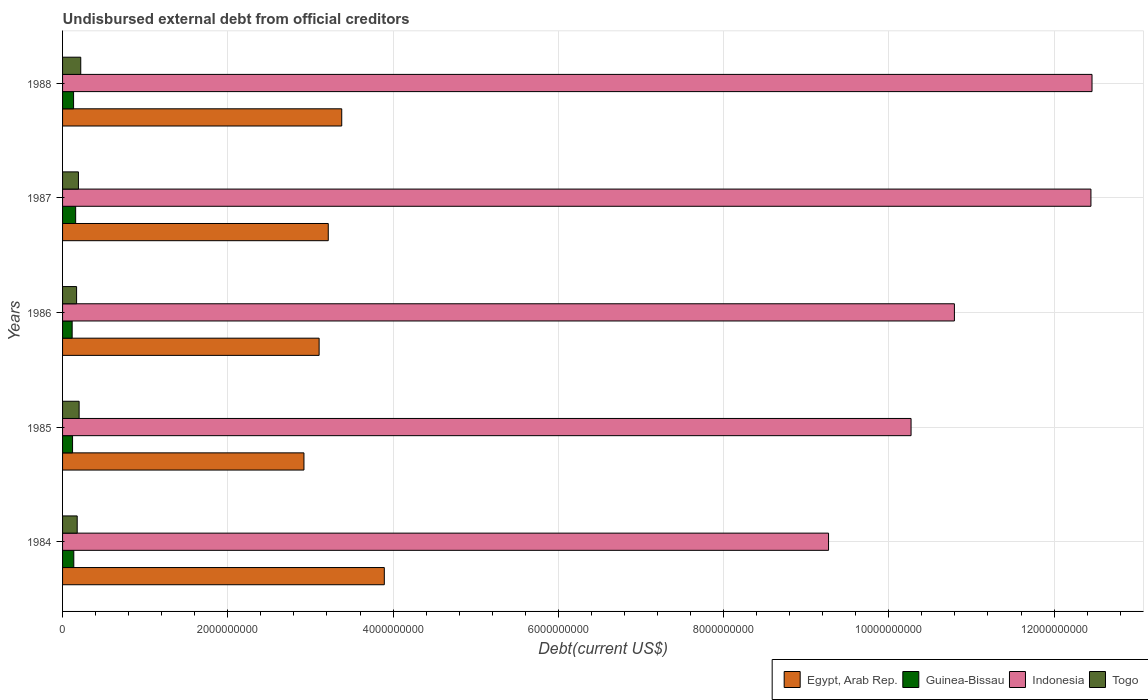How many different coloured bars are there?
Your answer should be very brief. 4. Are the number of bars per tick equal to the number of legend labels?
Your answer should be compact. Yes. Are the number of bars on each tick of the Y-axis equal?
Your answer should be compact. Yes. How many bars are there on the 2nd tick from the top?
Provide a succinct answer. 4. What is the label of the 4th group of bars from the top?
Ensure brevity in your answer.  1985. In how many cases, is the number of bars for a given year not equal to the number of legend labels?
Your response must be concise. 0. What is the total debt in Indonesia in 1985?
Give a very brief answer. 1.03e+1. Across all years, what is the maximum total debt in Togo?
Your response must be concise. 2.20e+08. Across all years, what is the minimum total debt in Egypt, Arab Rep.?
Your answer should be very brief. 2.92e+09. What is the total total debt in Guinea-Bissau in the graph?
Keep it short and to the point. 6.65e+08. What is the difference between the total debt in Guinea-Bissau in 1984 and that in 1985?
Provide a short and direct response. 1.49e+07. What is the difference between the total debt in Egypt, Arab Rep. in 1987 and the total debt in Guinea-Bissau in 1986?
Ensure brevity in your answer.  3.10e+09. What is the average total debt in Guinea-Bissau per year?
Your response must be concise. 1.33e+08. In the year 1988, what is the difference between the total debt in Indonesia and total debt in Togo?
Your answer should be compact. 1.22e+1. In how many years, is the total debt in Egypt, Arab Rep. greater than 7600000000 US$?
Provide a short and direct response. 0. What is the ratio of the total debt in Indonesia in 1984 to that in 1985?
Provide a succinct answer. 0.9. Is the total debt in Togo in 1984 less than that in 1988?
Provide a succinct answer. Yes. Is the difference between the total debt in Indonesia in 1985 and 1988 greater than the difference between the total debt in Togo in 1985 and 1988?
Your answer should be very brief. No. What is the difference between the highest and the second highest total debt in Egypt, Arab Rep.?
Offer a very short reply. 5.15e+08. What is the difference between the highest and the lowest total debt in Guinea-Bissau?
Ensure brevity in your answer.  4.24e+07. In how many years, is the total debt in Indonesia greater than the average total debt in Indonesia taken over all years?
Offer a very short reply. 2. What does the 3rd bar from the top in 1988 represents?
Offer a very short reply. Guinea-Bissau. What does the 4th bar from the bottom in 1988 represents?
Offer a very short reply. Togo. How many bars are there?
Offer a terse response. 20. Are all the bars in the graph horizontal?
Offer a very short reply. Yes. How many years are there in the graph?
Your response must be concise. 5. Does the graph contain any zero values?
Offer a very short reply. No. How are the legend labels stacked?
Your response must be concise. Horizontal. What is the title of the graph?
Your answer should be compact. Undisbursed external debt from official creditors. Does "Marshall Islands" appear as one of the legend labels in the graph?
Your answer should be compact. No. What is the label or title of the X-axis?
Ensure brevity in your answer.  Debt(current US$). What is the Debt(current US$) in Egypt, Arab Rep. in 1984?
Your response must be concise. 3.89e+09. What is the Debt(current US$) of Guinea-Bissau in 1984?
Your answer should be compact. 1.36e+08. What is the Debt(current US$) of Indonesia in 1984?
Keep it short and to the point. 9.27e+09. What is the Debt(current US$) of Togo in 1984?
Keep it short and to the point. 1.77e+08. What is the Debt(current US$) of Egypt, Arab Rep. in 1985?
Your response must be concise. 2.92e+09. What is the Debt(current US$) in Guinea-Bissau in 1985?
Your response must be concise. 1.21e+08. What is the Debt(current US$) in Indonesia in 1985?
Your response must be concise. 1.03e+1. What is the Debt(current US$) in Togo in 1985?
Your answer should be very brief. 2.00e+08. What is the Debt(current US$) of Egypt, Arab Rep. in 1986?
Keep it short and to the point. 3.11e+09. What is the Debt(current US$) in Guinea-Bissau in 1986?
Give a very brief answer. 1.16e+08. What is the Debt(current US$) of Indonesia in 1986?
Provide a short and direct response. 1.08e+1. What is the Debt(current US$) in Togo in 1986?
Your answer should be very brief. 1.70e+08. What is the Debt(current US$) of Egypt, Arab Rep. in 1987?
Provide a short and direct response. 3.22e+09. What is the Debt(current US$) of Guinea-Bissau in 1987?
Your answer should be compact. 1.59e+08. What is the Debt(current US$) in Indonesia in 1987?
Your answer should be very brief. 1.24e+1. What is the Debt(current US$) of Togo in 1987?
Your answer should be very brief. 1.92e+08. What is the Debt(current US$) of Egypt, Arab Rep. in 1988?
Provide a succinct answer. 3.38e+09. What is the Debt(current US$) of Guinea-Bissau in 1988?
Give a very brief answer. 1.33e+08. What is the Debt(current US$) in Indonesia in 1988?
Ensure brevity in your answer.  1.25e+1. What is the Debt(current US$) in Togo in 1988?
Make the answer very short. 2.20e+08. Across all years, what is the maximum Debt(current US$) in Egypt, Arab Rep.?
Make the answer very short. 3.89e+09. Across all years, what is the maximum Debt(current US$) in Guinea-Bissau?
Ensure brevity in your answer.  1.59e+08. Across all years, what is the maximum Debt(current US$) of Indonesia?
Give a very brief answer. 1.25e+1. Across all years, what is the maximum Debt(current US$) in Togo?
Offer a very short reply. 2.20e+08. Across all years, what is the minimum Debt(current US$) in Egypt, Arab Rep.?
Offer a terse response. 2.92e+09. Across all years, what is the minimum Debt(current US$) in Guinea-Bissau?
Give a very brief answer. 1.16e+08. Across all years, what is the minimum Debt(current US$) of Indonesia?
Your answer should be very brief. 9.27e+09. Across all years, what is the minimum Debt(current US$) of Togo?
Offer a very short reply. 1.70e+08. What is the total Debt(current US$) of Egypt, Arab Rep. in the graph?
Keep it short and to the point. 1.65e+1. What is the total Debt(current US$) in Guinea-Bissau in the graph?
Provide a short and direct response. 6.65e+08. What is the total Debt(current US$) of Indonesia in the graph?
Your answer should be very brief. 5.52e+1. What is the total Debt(current US$) of Togo in the graph?
Your answer should be very brief. 9.59e+08. What is the difference between the Debt(current US$) of Egypt, Arab Rep. in 1984 and that in 1985?
Offer a terse response. 9.72e+08. What is the difference between the Debt(current US$) of Guinea-Bissau in 1984 and that in 1985?
Keep it short and to the point. 1.49e+07. What is the difference between the Debt(current US$) of Indonesia in 1984 and that in 1985?
Offer a terse response. -9.99e+08. What is the difference between the Debt(current US$) of Togo in 1984 and that in 1985?
Make the answer very short. -2.33e+07. What is the difference between the Debt(current US$) of Egypt, Arab Rep. in 1984 and that in 1986?
Ensure brevity in your answer.  7.89e+08. What is the difference between the Debt(current US$) of Guinea-Bissau in 1984 and that in 1986?
Ensure brevity in your answer.  1.98e+07. What is the difference between the Debt(current US$) in Indonesia in 1984 and that in 1986?
Ensure brevity in your answer.  -1.52e+09. What is the difference between the Debt(current US$) of Togo in 1984 and that in 1986?
Make the answer very short. 7.38e+06. What is the difference between the Debt(current US$) of Egypt, Arab Rep. in 1984 and that in 1987?
Your answer should be compact. 6.78e+08. What is the difference between the Debt(current US$) of Guinea-Bissau in 1984 and that in 1987?
Provide a short and direct response. -2.26e+07. What is the difference between the Debt(current US$) of Indonesia in 1984 and that in 1987?
Your answer should be very brief. -3.18e+09. What is the difference between the Debt(current US$) in Togo in 1984 and that in 1987?
Your response must be concise. -1.50e+07. What is the difference between the Debt(current US$) in Egypt, Arab Rep. in 1984 and that in 1988?
Make the answer very short. 5.15e+08. What is the difference between the Debt(current US$) in Guinea-Bissau in 1984 and that in 1988?
Make the answer very short. 2.58e+06. What is the difference between the Debt(current US$) of Indonesia in 1984 and that in 1988?
Offer a terse response. -3.19e+09. What is the difference between the Debt(current US$) in Togo in 1984 and that in 1988?
Ensure brevity in your answer.  -4.31e+07. What is the difference between the Debt(current US$) in Egypt, Arab Rep. in 1985 and that in 1986?
Your answer should be compact. -1.84e+08. What is the difference between the Debt(current US$) of Guinea-Bissau in 1985 and that in 1986?
Your answer should be compact. 4.90e+06. What is the difference between the Debt(current US$) in Indonesia in 1985 and that in 1986?
Ensure brevity in your answer.  -5.25e+08. What is the difference between the Debt(current US$) in Togo in 1985 and that in 1986?
Make the answer very short. 3.06e+07. What is the difference between the Debt(current US$) of Egypt, Arab Rep. in 1985 and that in 1987?
Offer a very short reply. -2.94e+08. What is the difference between the Debt(current US$) in Guinea-Bissau in 1985 and that in 1987?
Offer a very short reply. -3.75e+07. What is the difference between the Debt(current US$) in Indonesia in 1985 and that in 1987?
Your answer should be compact. -2.18e+09. What is the difference between the Debt(current US$) of Togo in 1985 and that in 1987?
Make the answer very short. 8.30e+06. What is the difference between the Debt(current US$) in Egypt, Arab Rep. in 1985 and that in 1988?
Your response must be concise. -4.57e+08. What is the difference between the Debt(current US$) of Guinea-Bissau in 1985 and that in 1988?
Your answer should be very brief. -1.23e+07. What is the difference between the Debt(current US$) of Indonesia in 1985 and that in 1988?
Provide a succinct answer. -2.19e+09. What is the difference between the Debt(current US$) in Togo in 1985 and that in 1988?
Ensure brevity in your answer.  -1.98e+07. What is the difference between the Debt(current US$) in Egypt, Arab Rep. in 1986 and that in 1987?
Provide a succinct answer. -1.11e+08. What is the difference between the Debt(current US$) in Guinea-Bissau in 1986 and that in 1987?
Provide a short and direct response. -4.24e+07. What is the difference between the Debt(current US$) of Indonesia in 1986 and that in 1987?
Make the answer very short. -1.65e+09. What is the difference between the Debt(current US$) in Togo in 1986 and that in 1987?
Ensure brevity in your answer.  -2.23e+07. What is the difference between the Debt(current US$) in Egypt, Arab Rep. in 1986 and that in 1988?
Provide a succinct answer. -2.74e+08. What is the difference between the Debt(current US$) in Guinea-Bissau in 1986 and that in 1988?
Make the answer very short. -1.72e+07. What is the difference between the Debt(current US$) in Indonesia in 1986 and that in 1988?
Offer a very short reply. -1.67e+09. What is the difference between the Debt(current US$) in Togo in 1986 and that in 1988?
Offer a very short reply. -5.04e+07. What is the difference between the Debt(current US$) in Egypt, Arab Rep. in 1987 and that in 1988?
Offer a terse response. -1.63e+08. What is the difference between the Debt(current US$) in Guinea-Bissau in 1987 and that in 1988?
Offer a terse response. 2.52e+07. What is the difference between the Debt(current US$) in Indonesia in 1987 and that in 1988?
Keep it short and to the point. -1.31e+07. What is the difference between the Debt(current US$) in Togo in 1987 and that in 1988?
Keep it short and to the point. -2.81e+07. What is the difference between the Debt(current US$) of Egypt, Arab Rep. in 1984 and the Debt(current US$) of Guinea-Bissau in 1985?
Ensure brevity in your answer.  3.77e+09. What is the difference between the Debt(current US$) of Egypt, Arab Rep. in 1984 and the Debt(current US$) of Indonesia in 1985?
Provide a succinct answer. -6.38e+09. What is the difference between the Debt(current US$) in Egypt, Arab Rep. in 1984 and the Debt(current US$) in Togo in 1985?
Your response must be concise. 3.69e+09. What is the difference between the Debt(current US$) in Guinea-Bissau in 1984 and the Debt(current US$) in Indonesia in 1985?
Provide a succinct answer. -1.01e+1. What is the difference between the Debt(current US$) of Guinea-Bissau in 1984 and the Debt(current US$) of Togo in 1985?
Keep it short and to the point. -6.45e+07. What is the difference between the Debt(current US$) of Indonesia in 1984 and the Debt(current US$) of Togo in 1985?
Your response must be concise. 9.07e+09. What is the difference between the Debt(current US$) of Egypt, Arab Rep. in 1984 and the Debt(current US$) of Guinea-Bissau in 1986?
Your answer should be compact. 3.78e+09. What is the difference between the Debt(current US$) of Egypt, Arab Rep. in 1984 and the Debt(current US$) of Indonesia in 1986?
Make the answer very short. -6.90e+09. What is the difference between the Debt(current US$) in Egypt, Arab Rep. in 1984 and the Debt(current US$) in Togo in 1986?
Your answer should be very brief. 3.72e+09. What is the difference between the Debt(current US$) of Guinea-Bissau in 1984 and the Debt(current US$) of Indonesia in 1986?
Your response must be concise. -1.07e+1. What is the difference between the Debt(current US$) in Guinea-Bissau in 1984 and the Debt(current US$) in Togo in 1986?
Provide a short and direct response. -3.38e+07. What is the difference between the Debt(current US$) of Indonesia in 1984 and the Debt(current US$) of Togo in 1986?
Provide a succinct answer. 9.10e+09. What is the difference between the Debt(current US$) in Egypt, Arab Rep. in 1984 and the Debt(current US$) in Guinea-Bissau in 1987?
Give a very brief answer. 3.74e+09. What is the difference between the Debt(current US$) of Egypt, Arab Rep. in 1984 and the Debt(current US$) of Indonesia in 1987?
Give a very brief answer. -8.55e+09. What is the difference between the Debt(current US$) in Egypt, Arab Rep. in 1984 and the Debt(current US$) in Togo in 1987?
Your answer should be very brief. 3.70e+09. What is the difference between the Debt(current US$) of Guinea-Bissau in 1984 and the Debt(current US$) of Indonesia in 1987?
Your answer should be very brief. -1.23e+1. What is the difference between the Debt(current US$) of Guinea-Bissau in 1984 and the Debt(current US$) of Togo in 1987?
Your answer should be very brief. -5.62e+07. What is the difference between the Debt(current US$) in Indonesia in 1984 and the Debt(current US$) in Togo in 1987?
Ensure brevity in your answer.  9.08e+09. What is the difference between the Debt(current US$) of Egypt, Arab Rep. in 1984 and the Debt(current US$) of Guinea-Bissau in 1988?
Make the answer very short. 3.76e+09. What is the difference between the Debt(current US$) in Egypt, Arab Rep. in 1984 and the Debt(current US$) in Indonesia in 1988?
Make the answer very short. -8.57e+09. What is the difference between the Debt(current US$) of Egypt, Arab Rep. in 1984 and the Debt(current US$) of Togo in 1988?
Ensure brevity in your answer.  3.67e+09. What is the difference between the Debt(current US$) in Guinea-Bissau in 1984 and the Debt(current US$) in Indonesia in 1988?
Offer a very short reply. -1.23e+1. What is the difference between the Debt(current US$) in Guinea-Bissau in 1984 and the Debt(current US$) in Togo in 1988?
Provide a short and direct response. -8.43e+07. What is the difference between the Debt(current US$) in Indonesia in 1984 and the Debt(current US$) in Togo in 1988?
Your response must be concise. 9.05e+09. What is the difference between the Debt(current US$) of Egypt, Arab Rep. in 1985 and the Debt(current US$) of Guinea-Bissau in 1986?
Keep it short and to the point. 2.81e+09. What is the difference between the Debt(current US$) in Egypt, Arab Rep. in 1985 and the Debt(current US$) in Indonesia in 1986?
Keep it short and to the point. -7.87e+09. What is the difference between the Debt(current US$) of Egypt, Arab Rep. in 1985 and the Debt(current US$) of Togo in 1986?
Ensure brevity in your answer.  2.75e+09. What is the difference between the Debt(current US$) in Guinea-Bissau in 1985 and the Debt(current US$) in Indonesia in 1986?
Make the answer very short. -1.07e+1. What is the difference between the Debt(current US$) in Guinea-Bissau in 1985 and the Debt(current US$) in Togo in 1986?
Ensure brevity in your answer.  -4.87e+07. What is the difference between the Debt(current US$) in Indonesia in 1985 and the Debt(current US$) in Togo in 1986?
Provide a short and direct response. 1.01e+1. What is the difference between the Debt(current US$) in Egypt, Arab Rep. in 1985 and the Debt(current US$) in Guinea-Bissau in 1987?
Make the answer very short. 2.76e+09. What is the difference between the Debt(current US$) of Egypt, Arab Rep. in 1985 and the Debt(current US$) of Indonesia in 1987?
Give a very brief answer. -9.52e+09. What is the difference between the Debt(current US$) of Egypt, Arab Rep. in 1985 and the Debt(current US$) of Togo in 1987?
Offer a very short reply. 2.73e+09. What is the difference between the Debt(current US$) in Guinea-Bissau in 1985 and the Debt(current US$) in Indonesia in 1987?
Your answer should be very brief. -1.23e+1. What is the difference between the Debt(current US$) of Guinea-Bissau in 1985 and the Debt(current US$) of Togo in 1987?
Offer a very short reply. -7.10e+07. What is the difference between the Debt(current US$) in Indonesia in 1985 and the Debt(current US$) in Togo in 1987?
Provide a short and direct response. 1.01e+1. What is the difference between the Debt(current US$) in Egypt, Arab Rep. in 1985 and the Debt(current US$) in Guinea-Bissau in 1988?
Provide a short and direct response. 2.79e+09. What is the difference between the Debt(current US$) of Egypt, Arab Rep. in 1985 and the Debt(current US$) of Indonesia in 1988?
Make the answer very short. -9.54e+09. What is the difference between the Debt(current US$) in Egypt, Arab Rep. in 1985 and the Debt(current US$) in Togo in 1988?
Keep it short and to the point. 2.70e+09. What is the difference between the Debt(current US$) of Guinea-Bissau in 1985 and the Debt(current US$) of Indonesia in 1988?
Provide a succinct answer. -1.23e+1. What is the difference between the Debt(current US$) in Guinea-Bissau in 1985 and the Debt(current US$) in Togo in 1988?
Provide a short and direct response. -9.92e+07. What is the difference between the Debt(current US$) of Indonesia in 1985 and the Debt(current US$) of Togo in 1988?
Make the answer very short. 1.00e+1. What is the difference between the Debt(current US$) of Egypt, Arab Rep. in 1986 and the Debt(current US$) of Guinea-Bissau in 1987?
Give a very brief answer. 2.95e+09. What is the difference between the Debt(current US$) in Egypt, Arab Rep. in 1986 and the Debt(current US$) in Indonesia in 1987?
Provide a succinct answer. -9.34e+09. What is the difference between the Debt(current US$) of Egypt, Arab Rep. in 1986 and the Debt(current US$) of Togo in 1987?
Offer a very short reply. 2.91e+09. What is the difference between the Debt(current US$) in Guinea-Bissau in 1986 and the Debt(current US$) in Indonesia in 1987?
Provide a succinct answer. -1.23e+1. What is the difference between the Debt(current US$) in Guinea-Bissau in 1986 and the Debt(current US$) in Togo in 1987?
Your answer should be very brief. -7.60e+07. What is the difference between the Debt(current US$) of Indonesia in 1986 and the Debt(current US$) of Togo in 1987?
Provide a short and direct response. 1.06e+1. What is the difference between the Debt(current US$) in Egypt, Arab Rep. in 1986 and the Debt(current US$) in Guinea-Bissau in 1988?
Your answer should be very brief. 2.97e+09. What is the difference between the Debt(current US$) in Egypt, Arab Rep. in 1986 and the Debt(current US$) in Indonesia in 1988?
Your answer should be very brief. -9.35e+09. What is the difference between the Debt(current US$) of Egypt, Arab Rep. in 1986 and the Debt(current US$) of Togo in 1988?
Provide a succinct answer. 2.89e+09. What is the difference between the Debt(current US$) in Guinea-Bissau in 1986 and the Debt(current US$) in Indonesia in 1988?
Make the answer very short. -1.23e+1. What is the difference between the Debt(current US$) in Guinea-Bissau in 1986 and the Debt(current US$) in Togo in 1988?
Your answer should be very brief. -1.04e+08. What is the difference between the Debt(current US$) of Indonesia in 1986 and the Debt(current US$) of Togo in 1988?
Provide a succinct answer. 1.06e+1. What is the difference between the Debt(current US$) in Egypt, Arab Rep. in 1987 and the Debt(current US$) in Guinea-Bissau in 1988?
Your response must be concise. 3.08e+09. What is the difference between the Debt(current US$) of Egypt, Arab Rep. in 1987 and the Debt(current US$) of Indonesia in 1988?
Your answer should be very brief. -9.24e+09. What is the difference between the Debt(current US$) in Egypt, Arab Rep. in 1987 and the Debt(current US$) in Togo in 1988?
Your response must be concise. 3.00e+09. What is the difference between the Debt(current US$) of Guinea-Bissau in 1987 and the Debt(current US$) of Indonesia in 1988?
Provide a short and direct response. -1.23e+1. What is the difference between the Debt(current US$) of Guinea-Bissau in 1987 and the Debt(current US$) of Togo in 1988?
Make the answer very short. -6.16e+07. What is the difference between the Debt(current US$) in Indonesia in 1987 and the Debt(current US$) in Togo in 1988?
Keep it short and to the point. 1.22e+1. What is the average Debt(current US$) of Egypt, Arab Rep. per year?
Offer a very short reply. 3.30e+09. What is the average Debt(current US$) of Guinea-Bissau per year?
Your answer should be very brief. 1.33e+08. What is the average Debt(current US$) of Indonesia per year?
Your answer should be compact. 1.10e+1. What is the average Debt(current US$) in Togo per year?
Provide a succinct answer. 1.92e+08. In the year 1984, what is the difference between the Debt(current US$) in Egypt, Arab Rep. and Debt(current US$) in Guinea-Bissau?
Ensure brevity in your answer.  3.76e+09. In the year 1984, what is the difference between the Debt(current US$) of Egypt, Arab Rep. and Debt(current US$) of Indonesia?
Provide a short and direct response. -5.38e+09. In the year 1984, what is the difference between the Debt(current US$) of Egypt, Arab Rep. and Debt(current US$) of Togo?
Your response must be concise. 3.72e+09. In the year 1984, what is the difference between the Debt(current US$) in Guinea-Bissau and Debt(current US$) in Indonesia?
Provide a short and direct response. -9.13e+09. In the year 1984, what is the difference between the Debt(current US$) of Guinea-Bissau and Debt(current US$) of Togo?
Your answer should be very brief. -4.12e+07. In the year 1984, what is the difference between the Debt(current US$) in Indonesia and Debt(current US$) in Togo?
Your answer should be very brief. 9.09e+09. In the year 1985, what is the difference between the Debt(current US$) of Egypt, Arab Rep. and Debt(current US$) of Guinea-Bissau?
Provide a short and direct response. 2.80e+09. In the year 1985, what is the difference between the Debt(current US$) of Egypt, Arab Rep. and Debt(current US$) of Indonesia?
Offer a very short reply. -7.35e+09. In the year 1985, what is the difference between the Debt(current US$) in Egypt, Arab Rep. and Debt(current US$) in Togo?
Provide a succinct answer. 2.72e+09. In the year 1985, what is the difference between the Debt(current US$) of Guinea-Bissau and Debt(current US$) of Indonesia?
Your response must be concise. -1.01e+1. In the year 1985, what is the difference between the Debt(current US$) in Guinea-Bissau and Debt(current US$) in Togo?
Your answer should be compact. -7.93e+07. In the year 1985, what is the difference between the Debt(current US$) of Indonesia and Debt(current US$) of Togo?
Offer a terse response. 1.01e+1. In the year 1986, what is the difference between the Debt(current US$) of Egypt, Arab Rep. and Debt(current US$) of Guinea-Bissau?
Keep it short and to the point. 2.99e+09. In the year 1986, what is the difference between the Debt(current US$) of Egypt, Arab Rep. and Debt(current US$) of Indonesia?
Offer a very short reply. -7.69e+09. In the year 1986, what is the difference between the Debt(current US$) of Egypt, Arab Rep. and Debt(current US$) of Togo?
Provide a succinct answer. 2.94e+09. In the year 1986, what is the difference between the Debt(current US$) of Guinea-Bissau and Debt(current US$) of Indonesia?
Give a very brief answer. -1.07e+1. In the year 1986, what is the difference between the Debt(current US$) of Guinea-Bissau and Debt(current US$) of Togo?
Provide a short and direct response. -5.36e+07. In the year 1986, what is the difference between the Debt(current US$) of Indonesia and Debt(current US$) of Togo?
Make the answer very short. 1.06e+1. In the year 1987, what is the difference between the Debt(current US$) of Egypt, Arab Rep. and Debt(current US$) of Guinea-Bissau?
Provide a short and direct response. 3.06e+09. In the year 1987, what is the difference between the Debt(current US$) in Egypt, Arab Rep. and Debt(current US$) in Indonesia?
Your answer should be compact. -9.23e+09. In the year 1987, what is the difference between the Debt(current US$) in Egypt, Arab Rep. and Debt(current US$) in Togo?
Provide a succinct answer. 3.02e+09. In the year 1987, what is the difference between the Debt(current US$) of Guinea-Bissau and Debt(current US$) of Indonesia?
Provide a succinct answer. -1.23e+1. In the year 1987, what is the difference between the Debt(current US$) of Guinea-Bissau and Debt(current US$) of Togo?
Provide a succinct answer. -3.35e+07. In the year 1987, what is the difference between the Debt(current US$) in Indonesia and Debt(current US$) in Togo?
Provide a succinct answer. 1.23e+1. In the year 1988, what is the difference between the Debt(current US$) of Egypt, Arab Rep. and Debt(current US$) of Guinea-Bissau?
Make the answer very short. 3.25e+09. In the year 1988, what is the difference between the Debt(current US$) of Egypt, Arab Rep. and Debt(current US$) of Indonesia?
Provide a short and direct response. -9.08e+09. In the year 1988, what is the difference between the Debt(current US$) in Egypt, Arab Rep. and Debt(current US$) in Togo?
Offer a very short reply. 3.16e+09. In the year 1988, what is the difference between the Debt(current US$) of Guinea-Bissau and Debt(current US$) of Indonesia?
Your answer should be compact. -1.23e+1. In the year 1988, what is the difference between the Debt(current US$) in Guinea-Bissau and Debt(current US$) in Togo?
Give a very brief answer. -8.68e+07. In the year 1988, what is the difference between the Debt(current US$) of Indonesia and Debt(current US$) of Togo?
Keep it short and to the point. 1.22e+1. What is the ratio of the Debt(current US$) in Egypt, Arab Rep. in 1984 to that in 1985?
Provide a short and direct response. 1.33. What is the ratio of the Debt(current US$) of Guinea-Bissau in 1984 to that in 1985?
Offer a very short reply. 1.12. What is the ratio of the Debt(current US$) in Indonesia in 1984 to that in 1985?
Your answer should be very brief. 0.9. What is the ratio of the Debt(current US$) in Togo in 1984 to that in 1985?
Offer a very short reply. 0.88. What is the ratio of the Debt(current US$) in Egypt, Arab Rep. in 1984 to that in 1986?
Keep it short and to the point. 1.25. What is the ratio of the Debt(current US$) of Guinea-Bissau in 1984 to that in 1986?
Provide a succinct answer. 1.17. What is the ratio of the Debt(current US$) of Indonesia in 1984 to that in 1986?
Offer a terse response. 0.86. What is the ratio of the Debt(current US$) of Togo in 1984 to that in 1986?
Make the answer very short. 1.04. What is the ratio of the Debt(current US$) in Egypt, Arab Rep. in 1984 to that in 1987?
Your response must be concise. 1.21. What is the ratio of the Debt(current US$) in Indonesia in 1984 to that in 1987?
Provide a succinct answer. 0.74. What is the ratio of the Debt(current US$) of Togo in 1984 to that in 1987?
Ensure brevity in your answer.  0.92. What is the ratio of the Debt(current US$) of Egypt, Arab Rep. in 1984 to that in 1988?
Offer a very short reply. 1.15. What is the ratio of the Debt(current US$) of Guinea-Bissau in 1984 to that in 1988?
Ensure brevity in your answer.  1.02. What is the ratio of the Debt(current US$) in Indonesia in 1984 to that in 1988?
Provide a succinct answer. 0.74. What is the ratio of the Debt(current US$) of Togo in 1984 to that in 1988?
Provide a succinct answer. 0.8. What is the ratio of the Debt(current US$) in Egypt, Arab Rep. in 1985 to that in 1986?
Your answer should be very brief. 0.94. What is the ratio of the Debt(current US$) in Guinea-Bissau in 1985 to that in 1986?
Provide a succinct answer. 1.04. What is the ratio of the Debt(current US$) of Indonesia in 1985 to that in 1986?
Offer a terse response. 0.95. What is the ratio of the Debt(current US$) in Togo in 1985 to that in 1986?
Your response must be concise. 1.18. What is the ratio of the Debt(current US$) of Egypt, Arab Rep. in 1985 to that in 1987?
Your answer should be very brief. 0.91. What is the ratio of the Debt(current US$) in Guinea-Bissau in 1985 to that in 1987?
Offer a very short reply. 0.76. What is the ratio of the Debt(current US$) in Indonesia in 1985 to that in 1987?
Your answer should be compact. 0.83. What is the ratio of the Debt(current US$) in Togo in 1985 to that in 1987?
Provide a succinct answer. 1.04. What is the ratio of the Debt(current US$) of Egypt, Arab Rep. in 1985 to that in 1988?
Offer a very short reply. 0.86. What is the ratio of the Debt(current US$) of Guinea-Bissau in 1985 to that in 1988?
Offer a terse response. 0.91. What is the ratio of the Debt(current US$) of Indonesia in 1985 to that in 1988?
Make the answer very short. 0.82. What is the ratio of the Debt(current US$) in Togo in 1985 to that in 1988?
Keep it short and to the point. 0.91. What is the ratio of the Debt(current US$) in Egypt, Arab Rep. in 1986 to that in 1987?
Your answer should be very brief. 0.97. What is the ratio of the Debt(current US$) in Guinea-Bissau in 1986 to that in 1987?
Your response must be concise. 0.73. What is the ratio of the Debt(current US$) in Indonesia in 1986 to that in 1987?
Make the answer very short. 0.87. What is the ratio of the Debt(current US$) in Togo in 1986 to that in 1987?
Provide a short and direct response. 0.88. What is the ratio of the Debt(current US$) in Egypt, Arab Rep. in 1986 to that in 1988?
Offer a very short reply. 0.92. What is the ratio of the Debt(current US$) in Guinea-Bissau in 1986 to that in 1988?
Keep it short and to the point. 0.87. What is the ratio of the Debt(current US$) in Indonesia in 1986 to that in 1988?
Your answer should be compact. 0.87. What is the ratio of the Debt(current US$) of Togo in 1986 to that in 1988?
Offer a terse response. 0.77. What is the ratio of the Debt(current US$) of Egypt, Arab Rep. in 1987 to that in 1988?
Make the answer very short. 0.95. What is the ratio of the Debt(current US$) in Guinea-Bissau in 1987 to that in 1988?
Keep it short and to the point. 1.19. What is the ratio of the Debt(current US$) in Indonesia in 1987 to that in 1988?
Your answer should be compact. 1. What is the ratio of the Debt(current US$) of Togo in 1987 to that in 1988?
Keep it short and to the point. 0.87. What is the difference between the highest and the second highest Debt(current US$) in Egypt, Arab Rep.?
Offer a very short reply. 5.15e+08. What is the difference between the highest and the second highest Debt(current US$) of Guinea-Bissau?
Your response must be concise. 2.26e+07. What is the difference between the highest and the second highest Debt(current US$) in Indonesia?
Your answer should be very brief. 1.31e+07. What is the difference between the highest and the second highest Debt(current US$) in Togo?
Ensure brevity in your answer.  1.98e+07. What is the difference between the highest and the lowest Debt(current US$) of Egypt, Arab Rep.?
Provide a short and direct response. 9.72e+08. What is the difference between the highest and the lowest Debt(current US$) in Guinea-Bissau?
Provide a succinct answer. 4.24e+07. What is the difference between the highest and the lowest Debt(current US$) of Indonesia?
Provide a succinct answer. 3.19e+09. What is the difference between the highest and the lowest Debt(current US$) of Togo?
Give a very brief answer. 5.04e+07. 